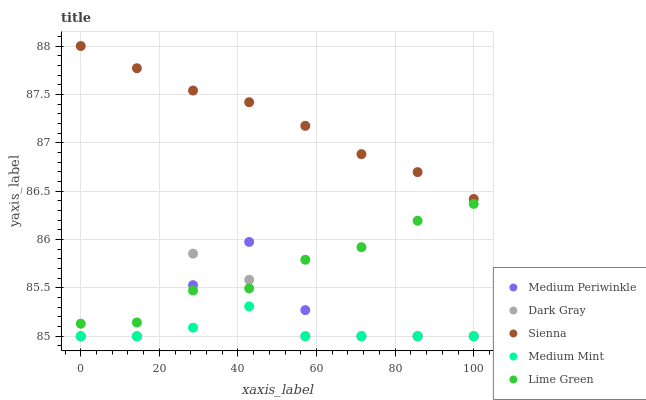Does Medium Mint have the minimum area under the curve?
Answer yes or no. Yes. Does Sienna have the maximum area under the curve?
Answer yes or no. Yes. Does Medium Periwinkle have the minimum area under the curve?
Answer yes or no. No. Does Medium Periwinkle have the maximum area under the curve?
Answer yes or no. No. Is Sienna the smoothest?
Answer yes or no. Yes. Is Dark Gray the roughest?
Answer yes or no. Yes. Is Medium Periwinkle the smoothest?
Answer yes or no. No. Is Medium Periwinkle the roughest?
Answer yes or no. No. Does Dark Gray have the lowest value?
Answer yes or no. Yes. Does Sienna have the lowest value?
Answer yes or no. No. Does Sienna have the highest value?
Answer yes or no. Yes. Does Medium Periwinkle have the highest value?
Answer yes or no. No. Is Medium Periwinkle less than Sienna?
Answer yes or no. Yes. Is Lime Green greater than Medium Mint?
Answer yes or no. Yes. Does Medium Periwinkle intersect Lime Green?
Answer yes or no. Yes. Is Medium Periwinkle less than Lime Green?
Answer yes or no. No. Is Medium Periwinkle greater than Lime Green?
Answer yes or no. No. Does Medium Periwinkle intersect Sienna?
Answer yes or no. No. 